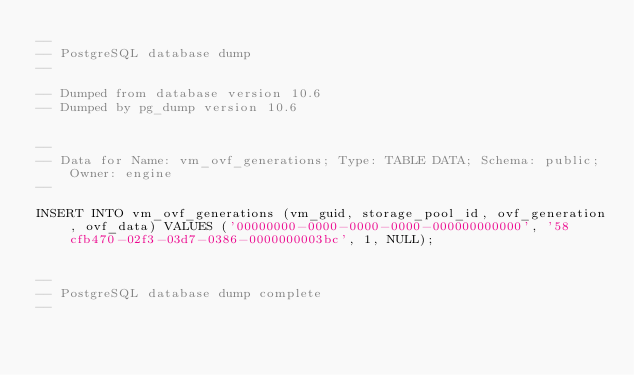Convert code to text. <code><loc_0><loc_0><loc_500><loc_500><_SQL_>--
-- PostgreSQL database dump
--

-- Dumped from database version 10.6
-- Dumped by pg_dump version 10.6


--
-- Data for Name: vm_ovf_generations; Type: TABLE DATA; Schema: public; Owner: engine
--

INSERT INTO vm_ovf_generations (vm_guid, storage_pool_id, ovf_generation, ovf_data) VALUES ('00000000-0000-0000-0000-000000000000', '58cfb470-02f3-03d7-0386-0000000003bc', 1, NULL);


--
-- PostgreSQL database dump complete
--

</code> 